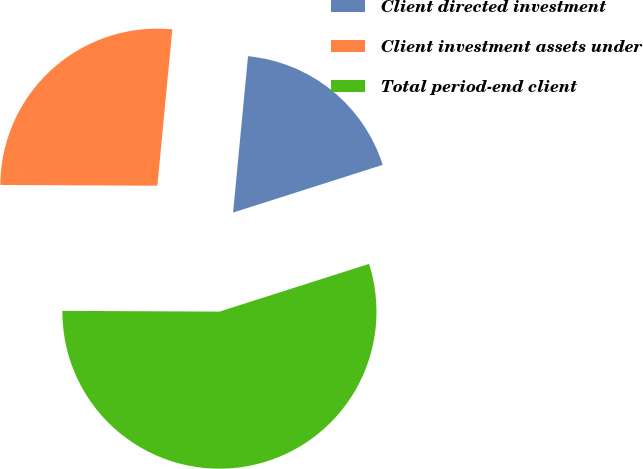Convert chart to OTSL. <chart><loc_0><loc_0><loc_500><loc_500><pie_chart><fcel>Client directed investment<fcel>Client investment assets under<fcel>Total period-end client<nl><fcel>18.57%<fcel>26.44%<fcel>54.99%<nl></chart> 